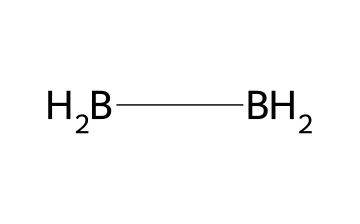What is the chemical name of this compound? The SMILES representation indicates the presence of three boron (B) atoms and six hydrogen (H) atoms. This corresponds to the chemical formula B2H6, which is known as diborane.
Answer: diborane How many hydrogen atoms are present in diborane? By analyzing the SMILES structure, it shows that there are two BH2 groups. Each group has two hydrogen atoms. Therefore, the total number of hydrogen atoms is 6.
Answer: six What is the hybridization of boron in diborane? In the case of diborane, the boron atoms are involved in bonding with hydrogen atoms in a way that allows them to adopt a trigonal bipyramidal geometry. This leads to sp3 hybridization.
Answer: sp3 What type of bonding occurs between boron and hydrogen in diborane? The bonding in diborane includes two types: terminal B-H bonds and a three-center two-electron bond involving the bridging hydrogen atoms. This results in a unique type of bonding known as multicenter bonding.
Answer: multicenter bonding Is diborane considered a suitable hydrogen storage material? Yes, diborane has a relatively high hydrogen content by weight (about 17.6%). Its ability to release hydrogen upon decomposition under appropriate conditions makes it an attractive candidate for hydrogen storage.
Answer: yes What angle do the terminal hydrogen atoms in diborane form? The terminal hydrogen atoms in diborane are arranged at approximately 120-degree angles relative to one another, due to the trigonal planar arrangement around each boron atom.
Answer: 120 degrees 